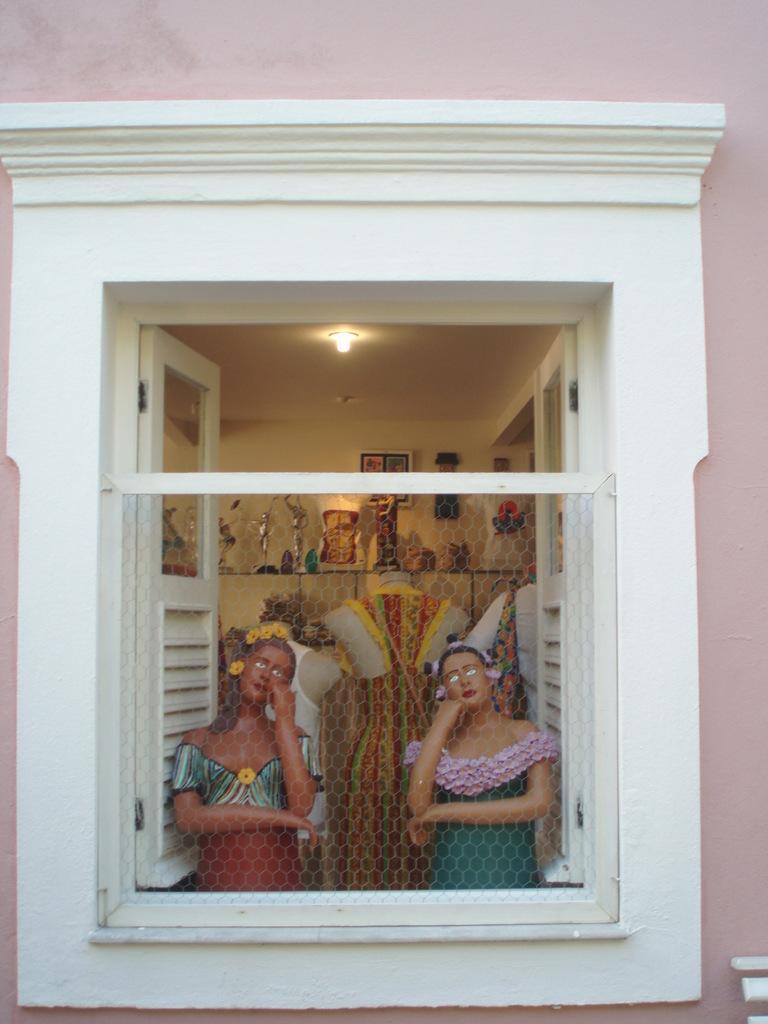In one or two sentences, can you explain what this image depicts? In the image we can see a window of a house. There are many toys and dolls in the image. There is a light attached to a roof. 